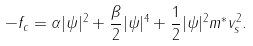<formula> <loc_0><loc_0><loc_500><loc_500>- f _ { c } = \alpha | \psi | ^ { 2 } + \frac { \beta } { 2 } | \psi | ^ { 4 } + \frac { 1 } { 2 } | \psi | ^ { 2 } m ^ { * } v _ { s } ^ { 2 } .</formula> 